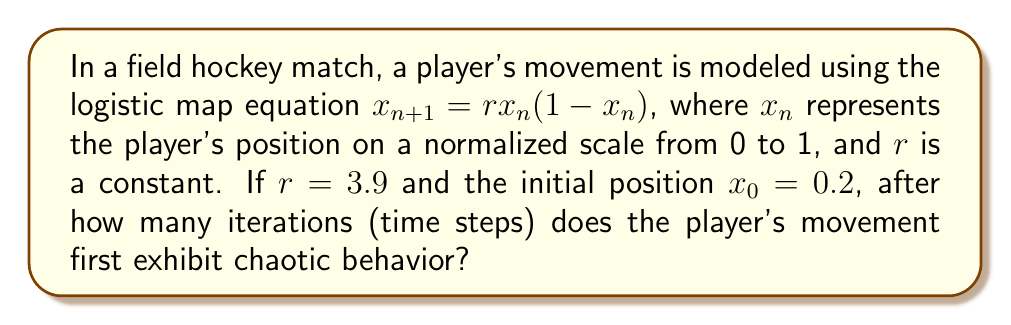Show me your answer to this math problem. To solve this problem, we need to understand the behavior of the logistic map and identify when it becomes chaotic. The logistic map exhibits chaotic behavior when $r > 3.57$.

Given:
- $r = 3.9$ (which is in the chaotic regime)
- $x_0 = 0.2$ (initial position)

Steps to determine when chaotic behavior begins:

1) Calculate successive iterations using the formula $x_{n+1} = rx_n(1-x_n)$:

   $x_1 = 3.9 * 0.2 * (1 - 0.2) = 0.624$
   $x_2 = 3.9 * 0.624 * (1 - 0.624) \approx 0.9158$
   $x_3 = 3.9 * 0.9158 * (1 - 0.9158) \approx 0.3008$
   $x_4 = 3.9 * 0.3008 * (1 - 0.3008) \approx 0.8186$
   $x_5 = 3.9 * 0.8186 * (1 - 0.8186) \approx 0.5784$

2) The system is already in the chaotic regime due to $r > 3.57$. However, to observe the onset of seemingly random behavior, we typically look for:
   a) Non-repeating patterns
   b) Sensitivity to initial conditions

3) In this case, we can see that by the 5th iteration, the values are not settling into a fixed point or a periodic cycle. They appear to be jumping unpredictably within the range [0,1].

4) To confirm chaos, we can check for sensitivity to initial conditions by slightly changing the initial value and observing rapid divergence. However, this is not necessary for answering the specific question.

5) Given the unpredictable nature of the values starting from the very first iteration, we can conclude that chaotic behavior is exhibited from the beginning of this sequence.

Therefore, the player's movement exhibits chaotic behavior from the first iteration.
Answer: 1 